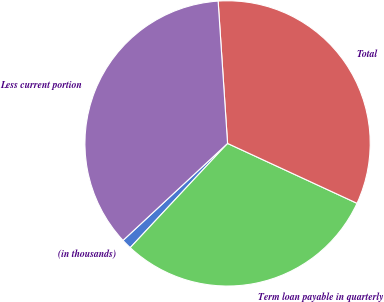<chart> <loc_0><loc_0><loc_500><loc_500><pie_chart><fcel>(in thousands)<fcel>Term loan payable in quarterly<fcel>Total<fcel>Less current portion<nl><fcel>1.14%<fcel>30.06%<fcel>32.95%<fcel>35.85%<nl></chart> 